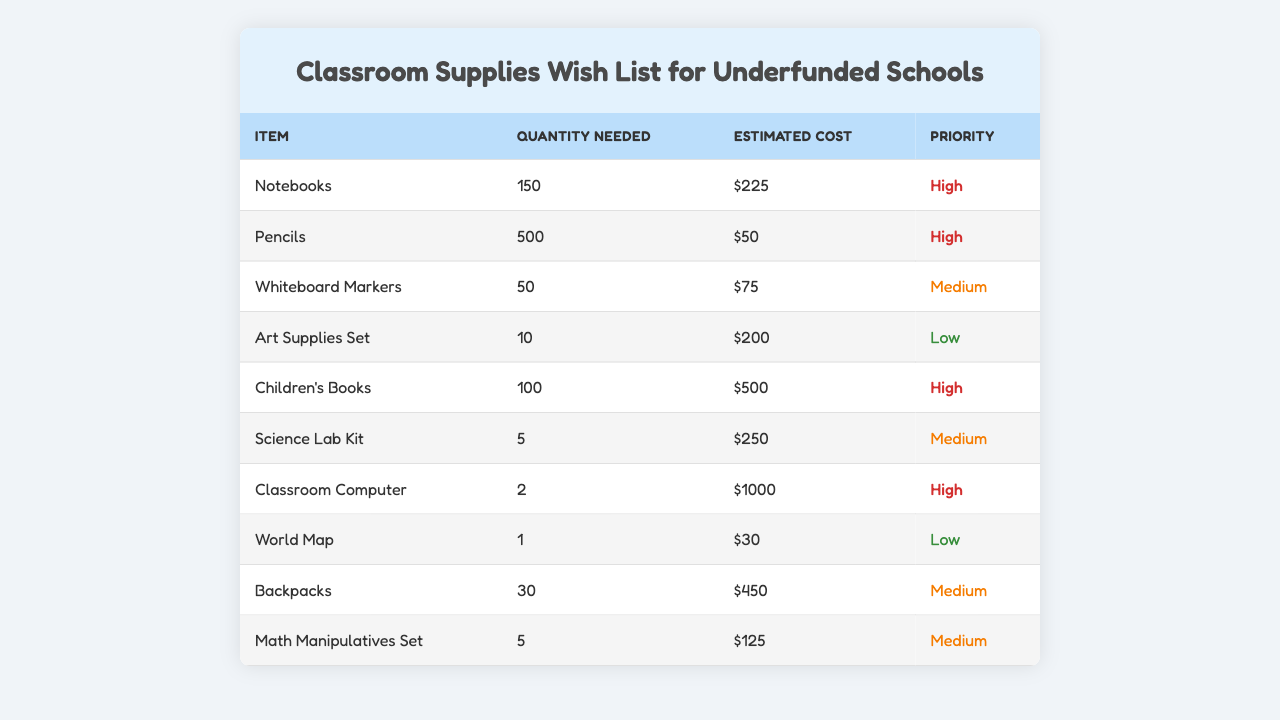What is the total estimated cost for all items on the wish list? To find the total estimated cost, we need to sum the estimated costs of all items: $225 + $50 + $75 + $200 + $500 + $250 + $1000 + $30 + $450 + $125 = $1905.
Answer: $1905 How many items have a high priority? By checking the priority column, there are 5 items categorized as high priority: Notebooks, Pencils, Children's Books, Classroom Computer, and Art Supplies Set.
Answer: 5 What is the average quantity needed for the items listed? We calculate the average quantity needed by summing all quantities (150 + 500 + 50 + 10 + 100 + 5 + 2 + 1 + 30 + 5) = 853, then dividing by the number of items, which is 10. Therefore, the average quantity is 853/10 = 85.3.
Answer: 85.3 Are there any items on the list that have a low priority? Checking the priority column, there are 3 items with low priority: Art Supplies Set, World Map, and Backpacks.
Answer: Yes Which item has the highest estimated cost? The Classroom Computer has the highest estimated cost of $1000, compared to other items on the list.
Answer: Classroom Computer How many more pencils are needed than notebooks? The number of pencils needed is 500, and the number of notebooks needed is 150. The difference is 500 - 150 = 350.
Answer: 350 What is the total quantity needed for all medium priority items? The medium priority items and their quantities are: Whiteboard Markers (50), Science Lab Kit (5), Backpacks (30), and Math Manipulatives Set (5). Adding these gives 50 + 5 + 30 + 5 = 90.
Answer: 90 Is the cost of art supplies set higher than the cost of the world map? The estimated cost of the Art Supplies Set is $200, and the World Map is $30. Since $200 is greater than $30, the statement is true.
Answer: Yes If we sum the quantities needed for high priority items only, what do we get? The quantities needed for high priority items are: Notebooks (150), Pencils (500), Children's Books (100), and Classroom Computer (2). Adding these: 150 + 500 + 100 + 2 = 752.
Answer: 752 Which items have an estimated cost between $70 and $300? The items that meet this criterion are: Whiteboard Markers ($75), Science Lab Kit ($250), and Math Manipulatives Set ($125). These three items fit the price range.
Answer: Whiteboard Markers, Science Lab Kit, Math Manipulatives Set 